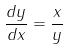<formula> <loc_0><loc_0><loc_500><loc_500>\frac { d y } { d x } = \frac { x } { y }</formula> 